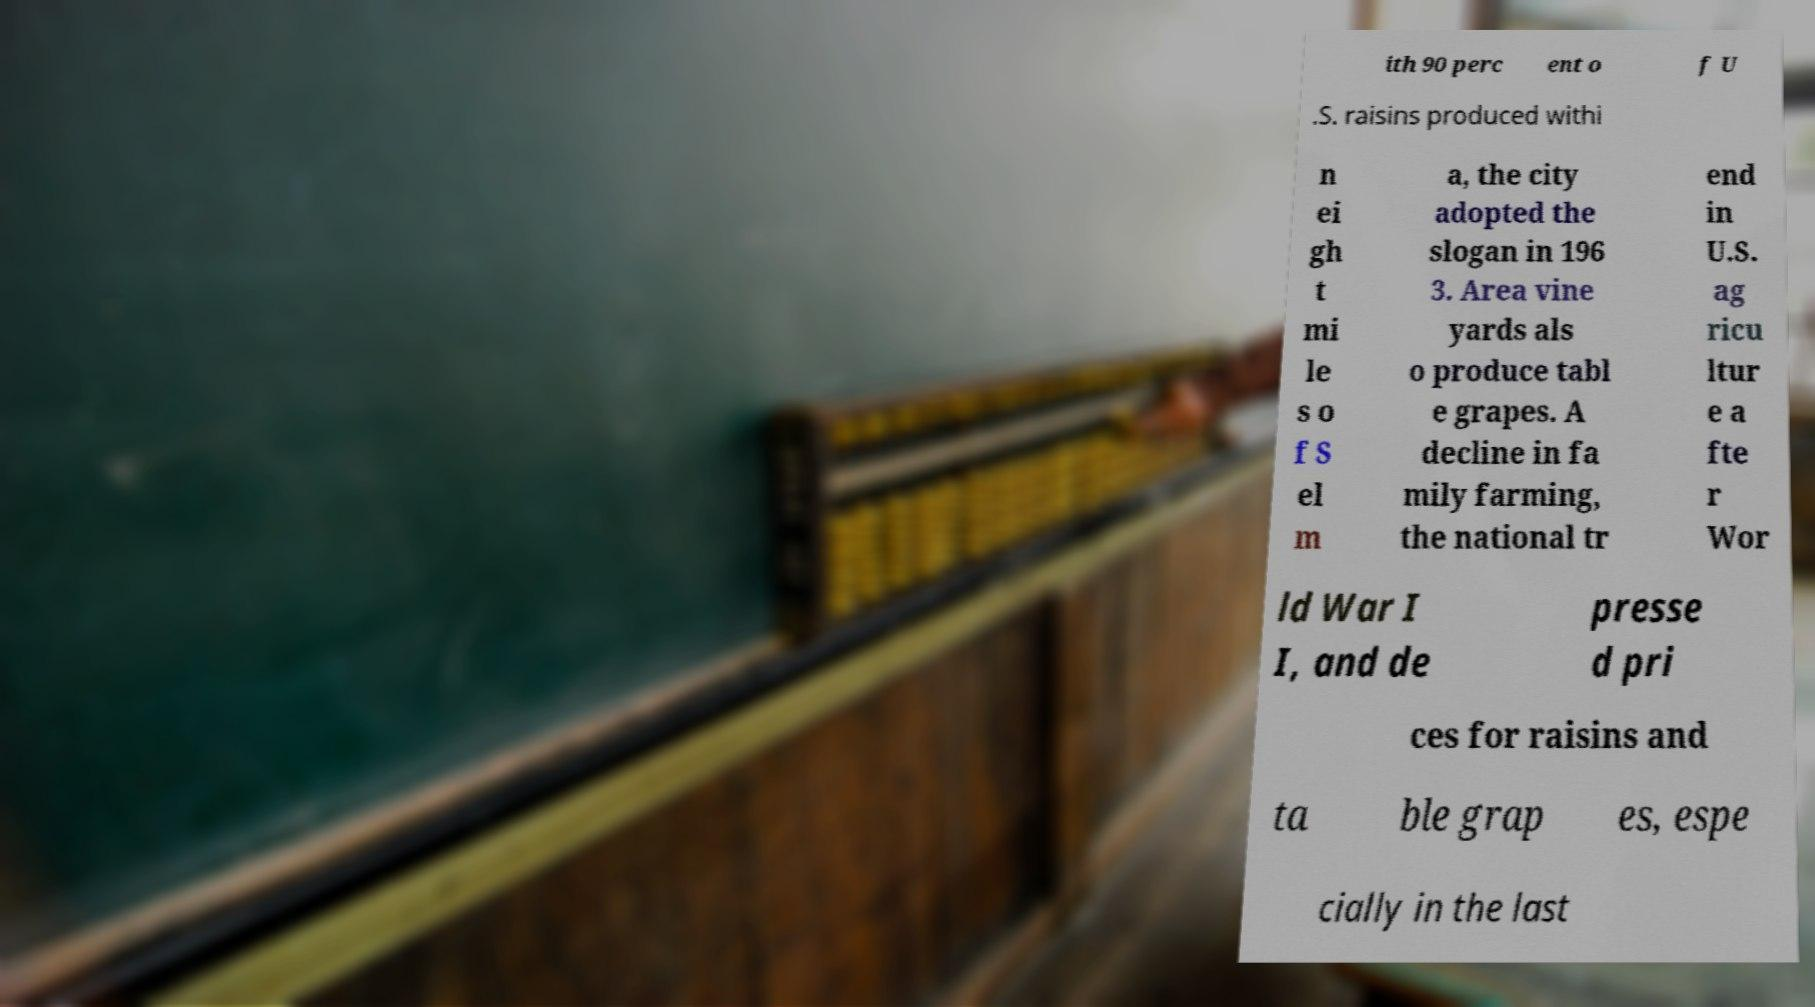Could you assist in decoding the text presented in this image and type it out clearly? ith 90 perc ent o f U .S. raisins produced withi n ei gh t mi le s o f S el m a, the city adopted the slogan in 196 3. Area vine yards als o produce tabl e grapes. A decline in fa mily farming, the national tr end in U.S. ag ricu ltur e a fte r Wor ld War I I, and de presse d pri ces for raisins and ta ble grap es, espe cially in the last 